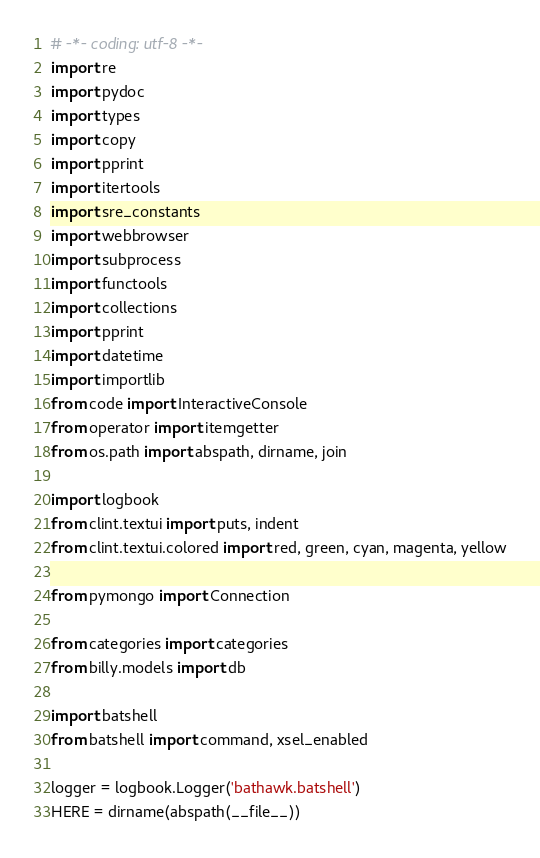<code> <loc_0><loc_0><loc_500><loc_500><_Python_># -*- coding: utf-8 -*-
import re
import pydoc
import types
import copy
import pprint
import itertools
import sre_constants
import webbrowser
import subprocess
import functools
import collections
import pprint
import datetime
import importlib
from code import InteractiveConsole
from operator import itemgetter
from os.path import abspath, dirname, join

import logbook
from clint.textui import puts, indent
from clint.textui.colored import red, green, cyan, magenta, yellow

from pymongo import Connection

from categories import categories
from billy.models import db

import batshell
from batshell import command, xsel_enabled

logger = logbook.Logger('bathawk.batshell')
HERE = dirname(abspath(__file__))

</code> 